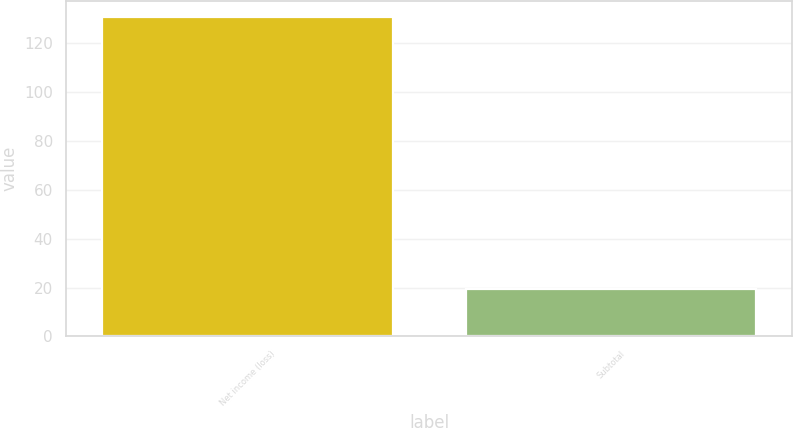Convert chart to OTSL. <chart><loc_0><loc_0><loc_500><loc_500><bar_chart><fcel>Net income (loss)<fcel>Subtotal<nl><fcel>131<fcel>19.4<nl></chart> 